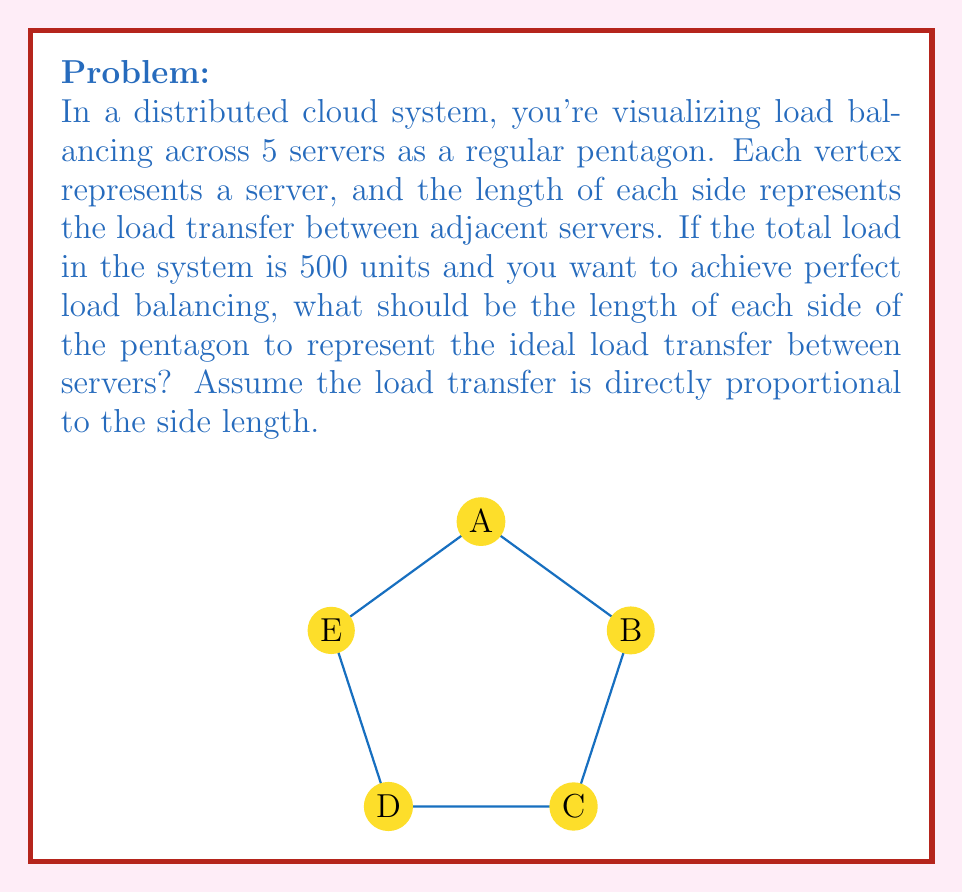What is the answer to this math problem? Let's approach this step-by-step:

1) In a perfectly balanced system, each server should handle an equal load. With 5 servers and a total load of 500 units:

   Load per server = $\frac{500}{5} = 100$ units

2) In a regular pentagon, there are 5 sides, each representing the load transfer between adjacent servers. The sum of these transfers should equal the total load in the system:

   $5x = 500$, where $x$ is the load transfer represented by each side

3) Solving for $x$:

   $x = \frac{500}{5} = 100$ units

4) Now, we need to determine the length of each side to represent 100 units of load transfer. Let's assume a scale where 1 unit of length represents 10 units of load.

5) Therefore, the length of each side should be:

   $\frac{100}{10} = 10$ units

This means that in our geometric representation, each side of the pentagon should have a length of 10 units to represent the ideal load transfer of 100 units between adjacent servers in a perfectly balanced system.
Answer: 10 units 